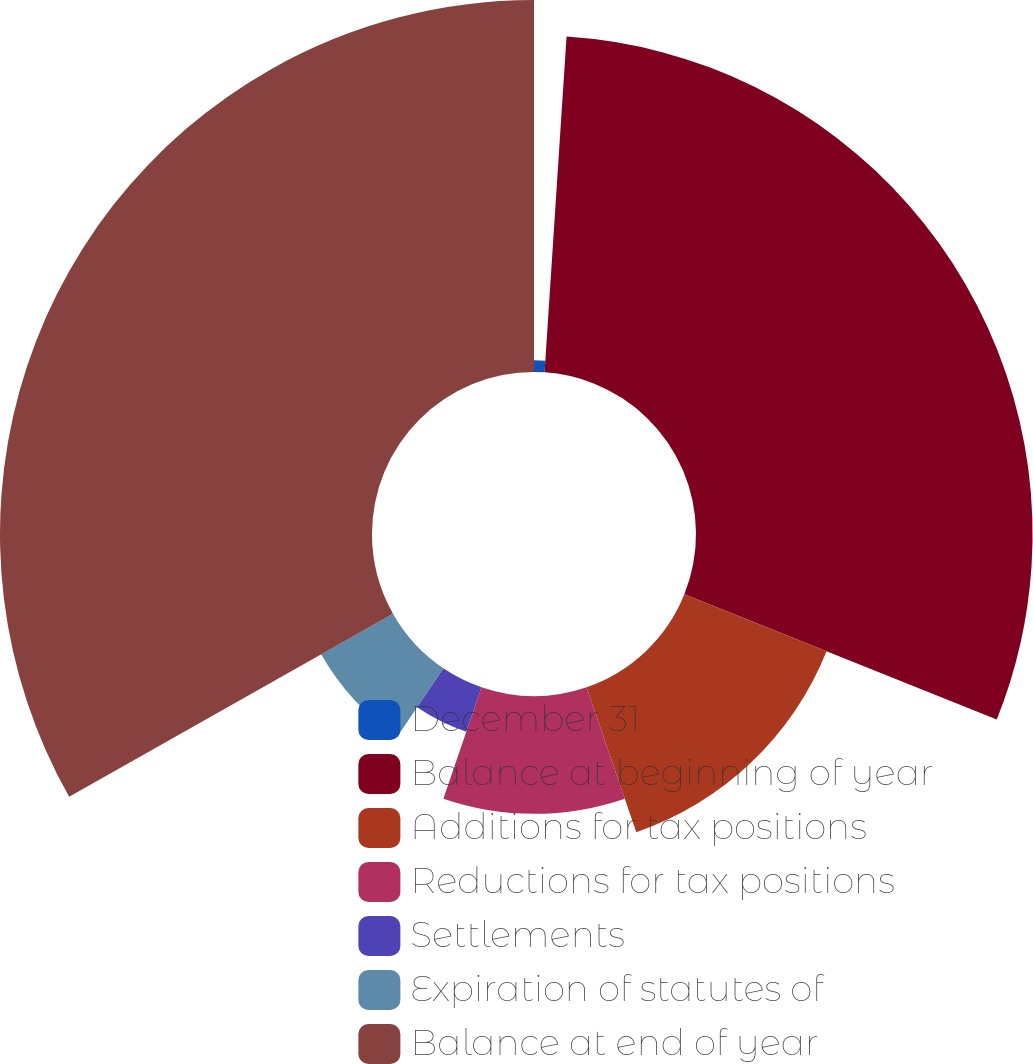<chart> <loc_0><loc_0><loc_500><loc_500><pie_chart><fcel>December 31<fcel>Balance at beginning of year<fcel>Additions for tax positions<fcel>Reductions for tax positions<fcel>Settlements<fcel>Expiration of statutes of<fcel>Balance at end of year<nl><fcel>1.04%<fcel>30.03%<fcel>13.67%<fcel>10.51%<fcel>4.2%<fcel>7.36%<fcel>33.19%<nl></chart> 